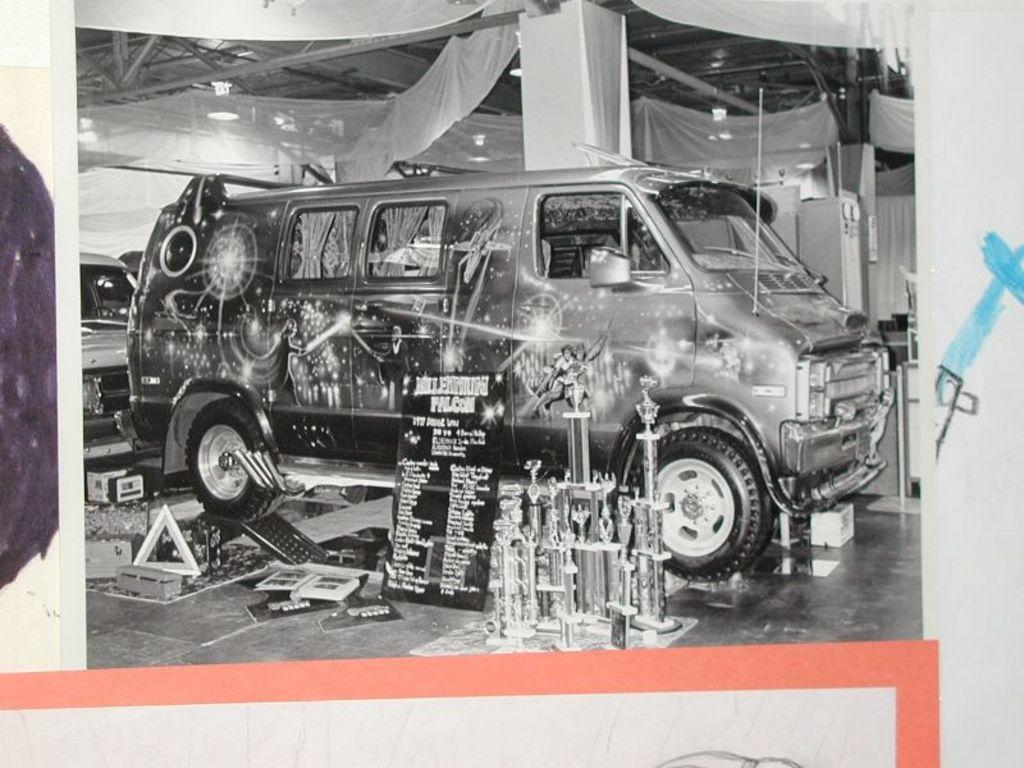How many sticks are present in the image? There is no information provided about sticks in the image. Is there an agreement visible in the image? There is no information provided about an agreement in the image. Can you see any signs of regret in the image? There is no information provided about any signs of regret in the image. 